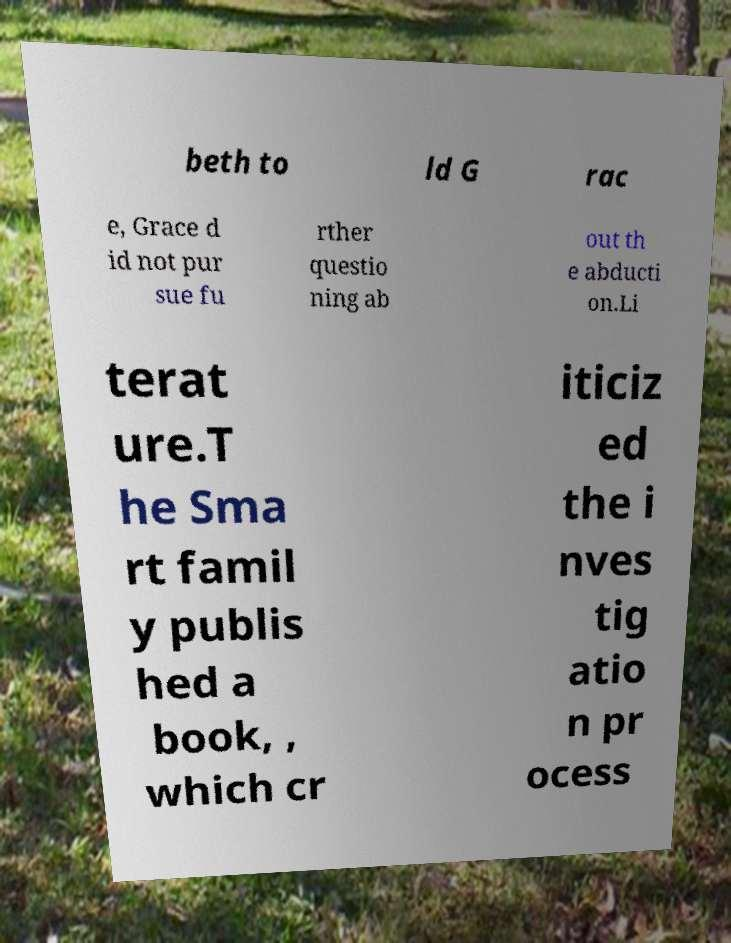Could you extract and type out the text from this image? beth to ld G rac e, Grace d id not pur sue fu rther questio ning ab out th e abducti on.Li terat ure.T he Sma rt famil y publis hed a book, , which cr iticiz ed the i nves tig atio n pr ocess 